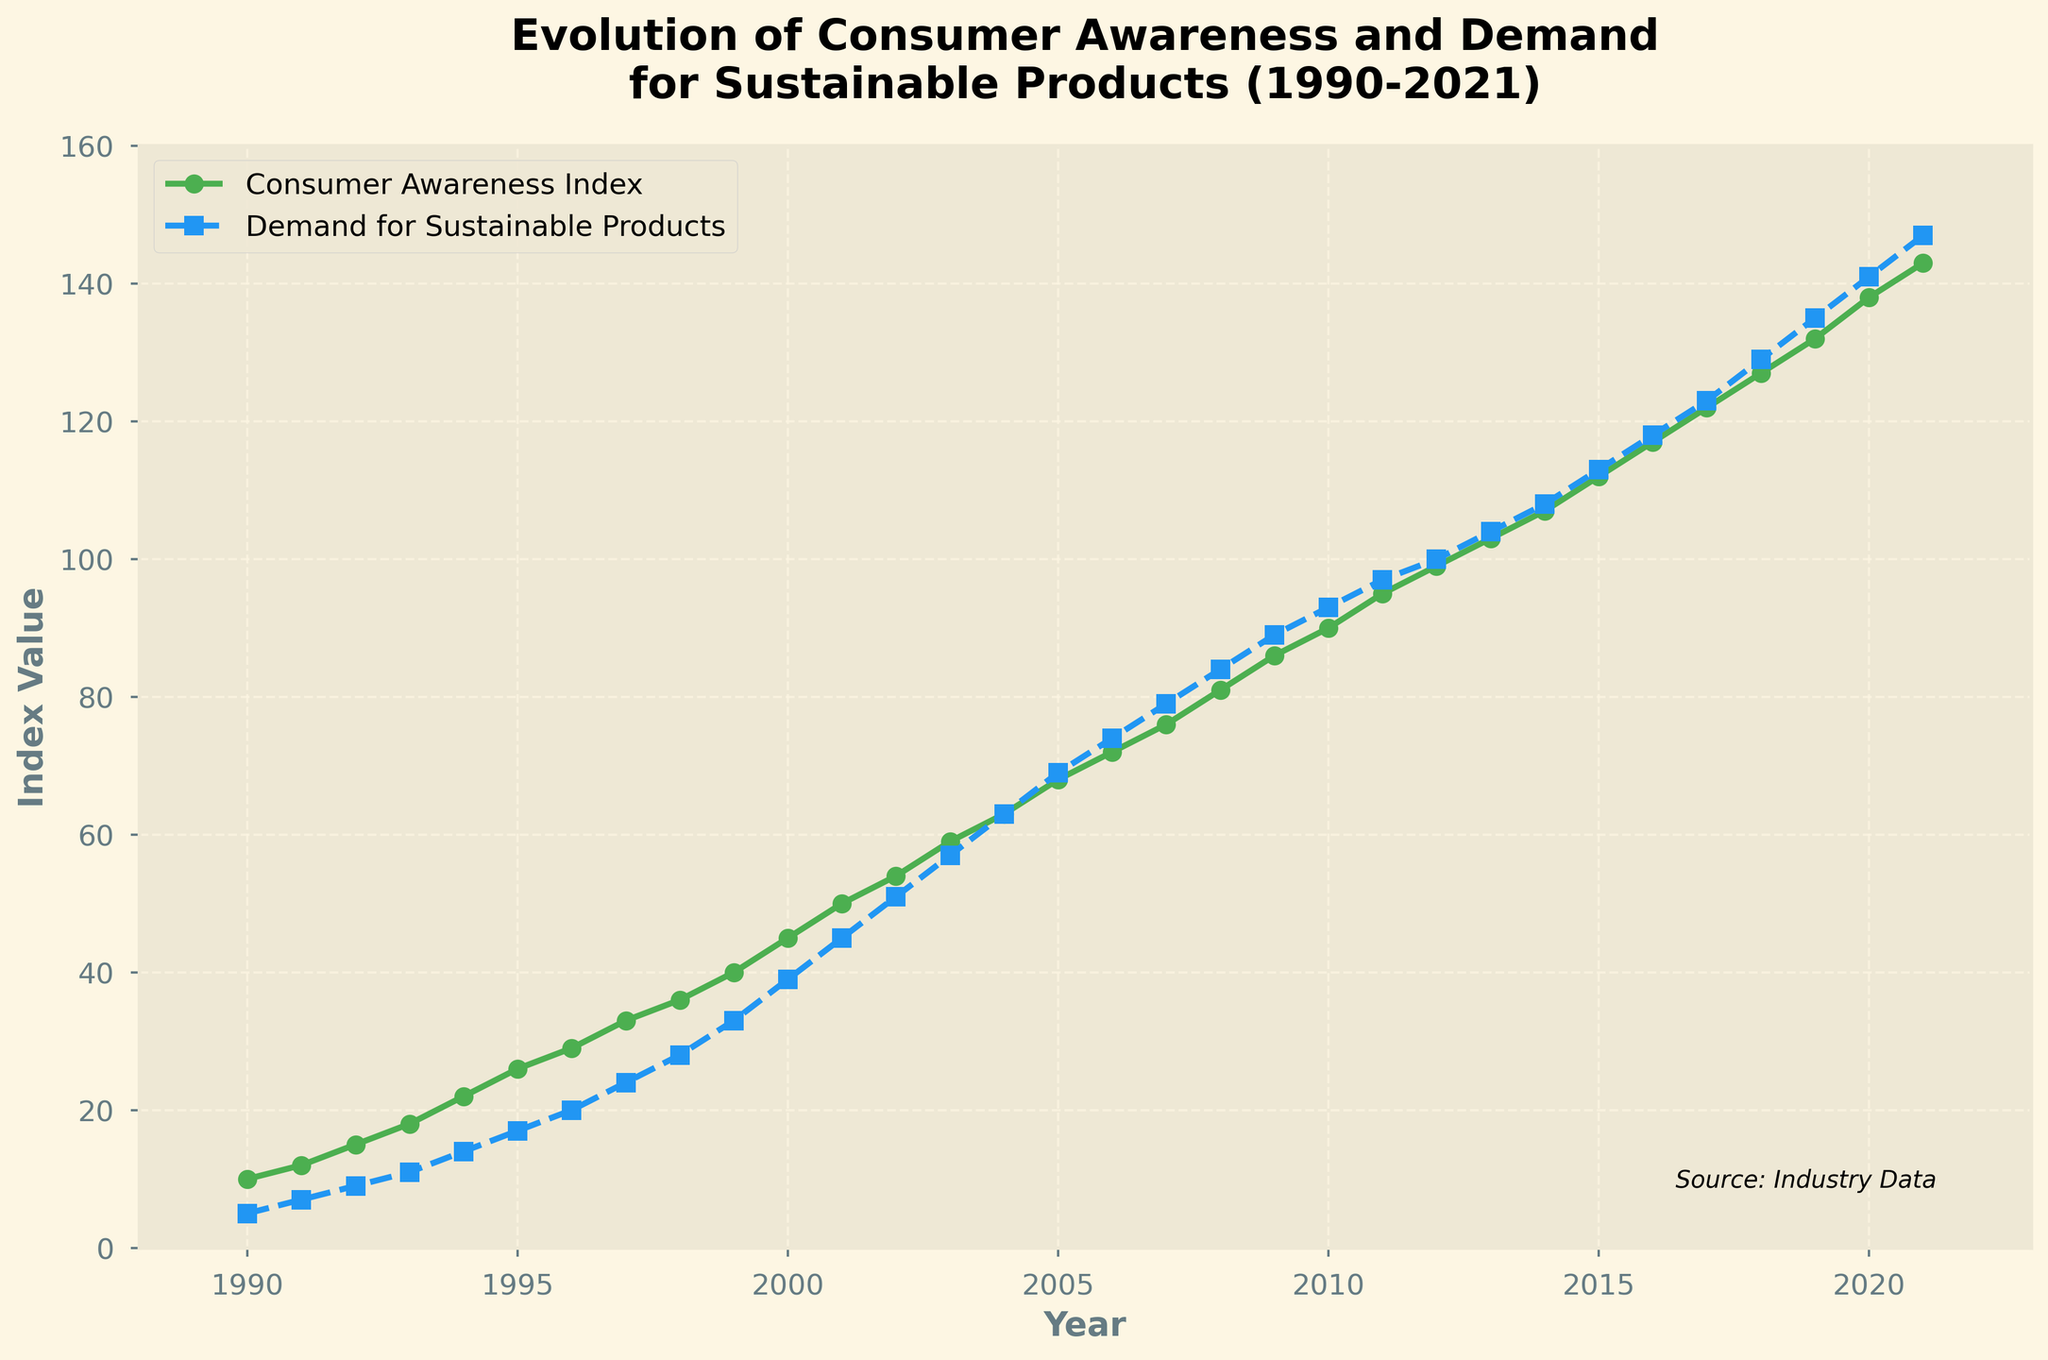What is the title of the figure? The title is displayed at the top of the figure, highlighting the main subject of the plot.
Answer: Evolution of Consumer Awareness and Demand for Sustainable Products (1990-2021) What is the trend in the Consumer Awareness Index from 1990 to 2021? The Consumer Awareness Index shows a continual increase over the years, which can be observed by the upward trajectory of the green line in the plot.
Answer: Increasing How does the Demand for Sustainable Products in 2021 compare to that in 1990? To compare the values, observe the blue line at the years 1990 and 2021. The index value increased from 5 in 1990 to 147 in 2021.
Answer: Much higher What is the highest index value for Consumer Awareness observed in the figure? The highest value can be identified as the maximum y-value reached by the green line in the plot.
Answer: 143 Which year shows the first instance when the Demand for Sustainable Products exceeds 100? Locate the year when the blue line crosses the y-axis value of 100.
Answer: 2012 Between which years did the Consumer Awareness Index experience the most significant increase? Look at the steepest part of the green line to identify the interval where the slope is the greatest.
Answer: 2009 to 2010 What is the range of the Demand for Sustainable Products from the beginning to the end of the time period? The range is calculated by subtracting the 1990 value of the Demand for Sustainable Products from the 2021 value.
Answer: 147 - 5 = 142 Were there any years when the Consumer Awareness Index was equal to the Demand for Sustainable Products? Check for instances where the green and blue lines intersect in the plot.
Answer: Yes, in 2012 What is the approximate average value of the Consumer Awareness Index from 2000 to 2010? Sum the index values from 2000 to 2010 and divide by the number of years (11). (45+50+54+59+63+68+72+76+81+86+90)/11 = 694/11
Answer: 63 Is there a visible pattern in the data indicating that as consumer awareness increases, demand for sustainable products also increases? From the visual trend where both the green and blue lines increase together consistently, it suggests a pattern of increased demand with increased awareness.
Answer: Yes 